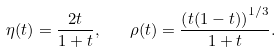Convert formula to latex. <formula><loc_0><loc_0><loc_500><loc_500>\eta ( t ) = \frac { 2 t } { 1 + t } , \quad \rho ( t ) = \frac { \left ( t ( 1 - t ) \right ) ^ { 1 / 3 } } { 1 + t } .</formula> 